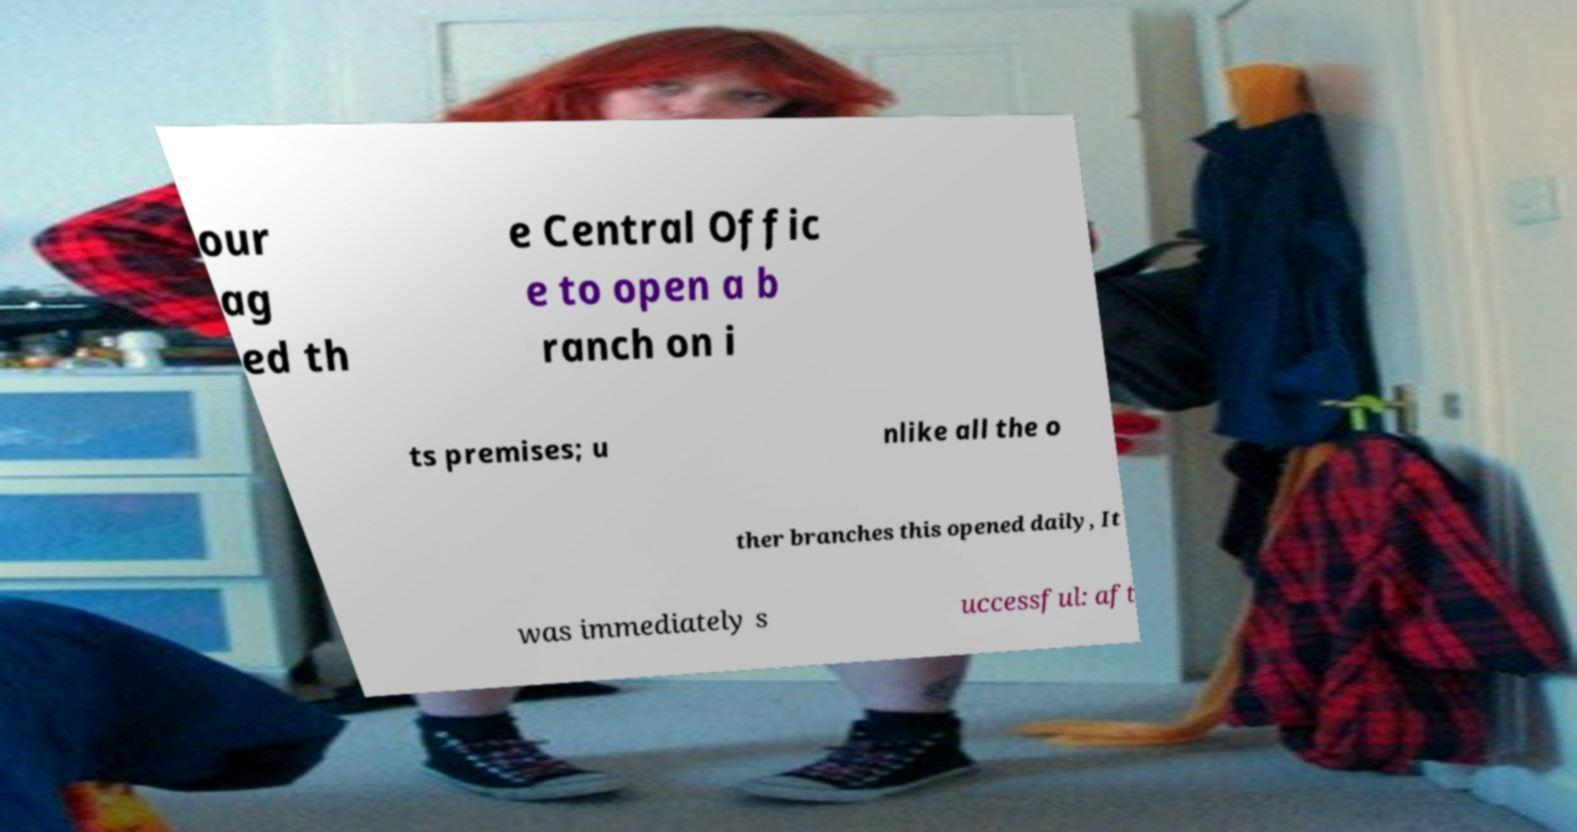For documentation purposes, I need the text within this image transcribed. Could you provide that? our ag ed th e Central Offic e to open a b ranch on i ts premises; u nlike all the o ther branches this opened daily, It was immediately s uccessful: aft 